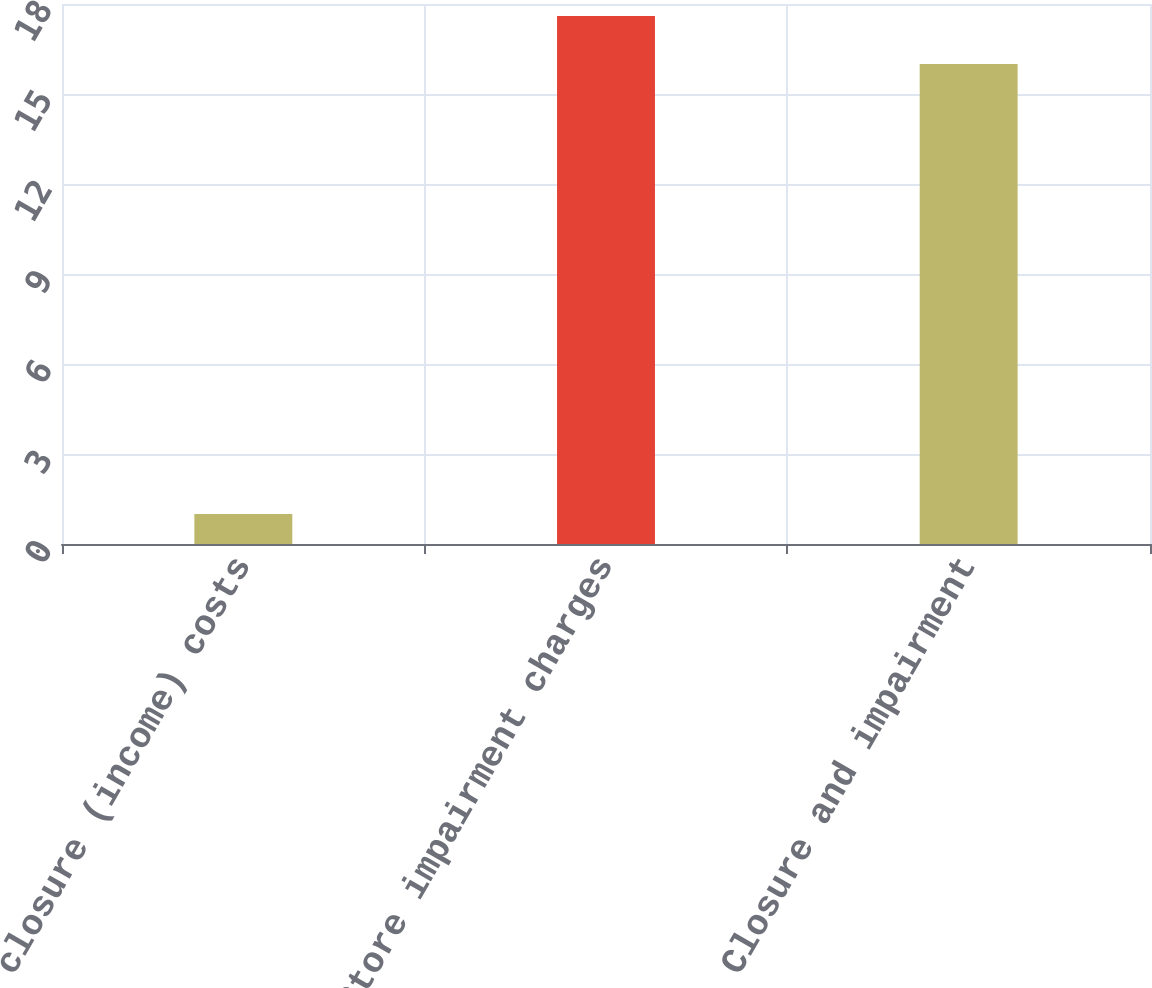Convert chart to OTSL. <chart><loc_0><loc_0><loc_500><loc_500><bar_chart><fcel>Store closure (income) costs<fcel>Store impairment charges<fcel>Closure and impairment<nl><fcel>1<fcel>17.6<fcel>16<nl></chart> 